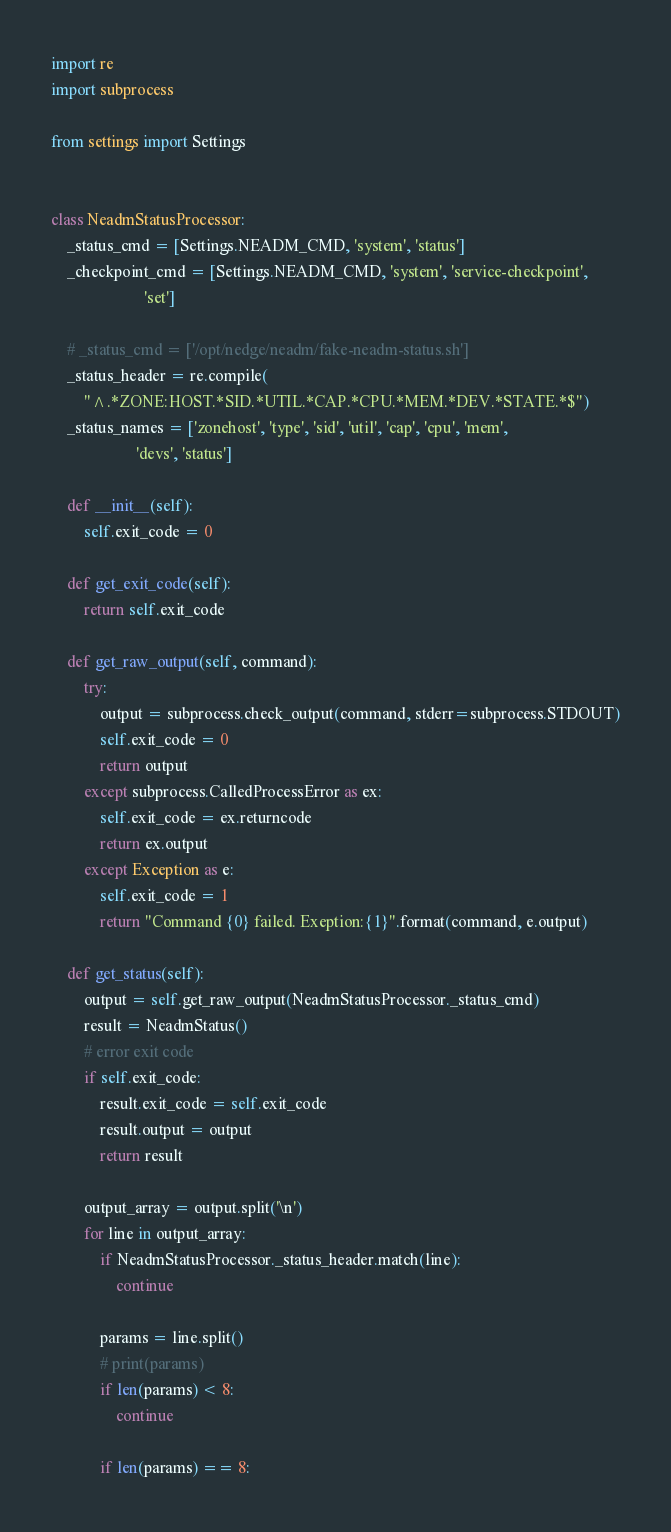<code> <loc_0><loc_0><loc_500><loc_500><_Python_>import re
import subprocess

from settings import Settings


class NeadmStatusProcessor:
    _status_cmd = [Settings.NEADM_CMD, 'system', 'status']
    _checkpoint_cmd = [Settings.NEADM_CMD, 'system', 'service-checkpoint',
                       'set']

    # _status_cmd = ['/opt/nedge/neadm/fake-neadm-status.sh']
    _status_header = re.compile(
        "^.*ZONE:HOST.*SID.*UTIL.*CAP.*CPU.*MEM.*DEV.*STATE.*$")
    _status_names = ['zonehost', 'type', 'sid', 'util', 'cap', 'cpu', 'mem',
                     'devs', 'status']

    def __init__(self):
        self.exit_code = 0

    def get_exit_code(self):
        return self.exit_code

    def get_raw_output(self, command):
        try:
            output = subprocess.check_output(command, stderr=subprocess.STDOUT)
            self.exit_code = 0
            return output
        except subprocess.CalledProcessError as ex:
            self.exit_code = ex.returncode
            return ex.output
        except Exception as e:
            self.exit_code = 1
            return "Command {0} failed. Exeption:{1}".format(command, e.output)

    def get_status(self):
        output = self.get_raw_output(NeadmStatusProcessor._status_cmd)
        result = NeadmStatus()
        # error exit code
        if self.exit_code:
            result.exit_code = self.exit_code
            result.output = output
            return result

        output_array = output.split('\n')
        for line in output_array:
            if NeadmStatusProcessor._status_header.match(line):
                continue

            params = line.split()
            # print(params)
            if len(params) < 8:
                continue

            if len(params) == 8:</code> 